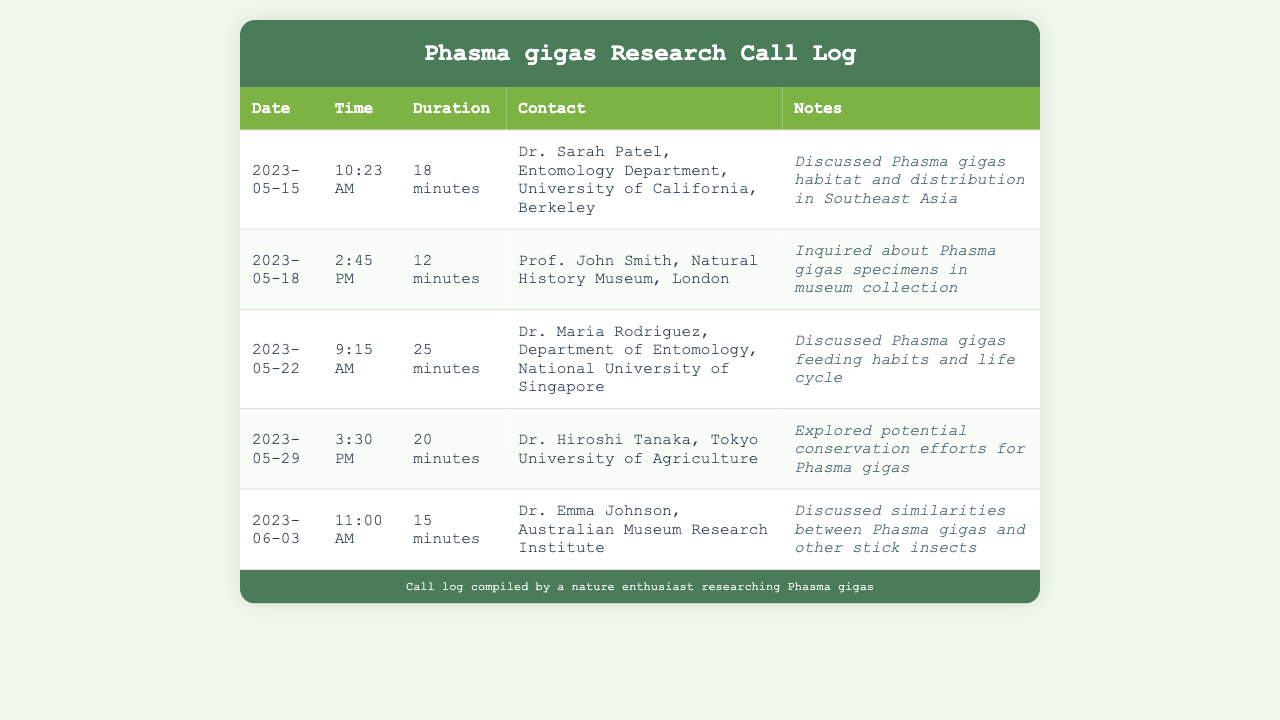What is the date of the first call? The first call was on May 15, 2023, according to the record.
Answer: May 15, 2023 Who is the contact for the fifth call? The fifth call was with Dr. Emma Johnson, as indicated in the document.
Answer: Dr. Emma Johnson What was the duration of the call with Dr. Maria Rodriguez? The call with Dr. Maria Rodriguez lasted for 25 minutes, as stated in the log.
Answer: 25 minutes How many total calls are recorded in the document? There are five calls listed in the document, one for each entry.
Answer: 5 What topic was discussed during the call with Dr. Hiroshi Tanaka? The call with Dr. Hiroshi Tanaka explored potential conservation efforts for Phasma gigas.
Answer: Conservation efforts Which university does Dr. Sarah Patel belong to? Dr. Sarah Patel is associated with the University of California, Berkeley, based on the entry.
Answer: University of California, Berkeley What was the time of the call on May 22? The call on May 22 took place at 9:15 AM, as provided in the table.
Answer: 9:15 AM Who was consulted regarding Phasma gigas specimens? Prof. John Smith was consulted about specimens in the museum collection.
Answer: Prof. John Smith 